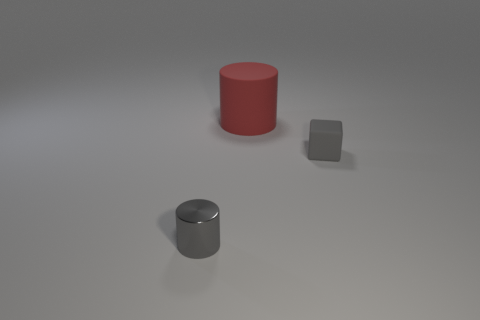What shape is the object that is the same color as the small shiny cylinder?
Make the answer very short. Cube. What is the red thing made of?
Make the answer very short. Rubber. How many objects are matte blocks or tiny cylinders?
Offer a very short reply. 2. There is a gray object left of the block; does it have the same size as the matte object in front of the large red matte thing?
Give a very brief answer. Yes. How many other things are the same size as the red cylinder?
Your response must be concise. 0. What number of objects are gray things on the left side of the tiny cube or cylinders in front of the tiny gray matte object?
Provide a succinct answer. 1. Is the material of the big red thing the same as the small object that is in front of the tiny block?
Keep it short and to the point. No. What number of other objects are there of the same shape as the tiny gray metal thing?
Keep it short and to the point. 1. There is a cylinder in front of the big red rubber cylinder behind the gray thing on the right side of the red rubber cylinder; what is its material?
Your response must be concise. Metal. Are there an equal number of tiny cylinders that are on the left side of the gray cylinder and gray metallic objects?
Your answer should be compact. No. 